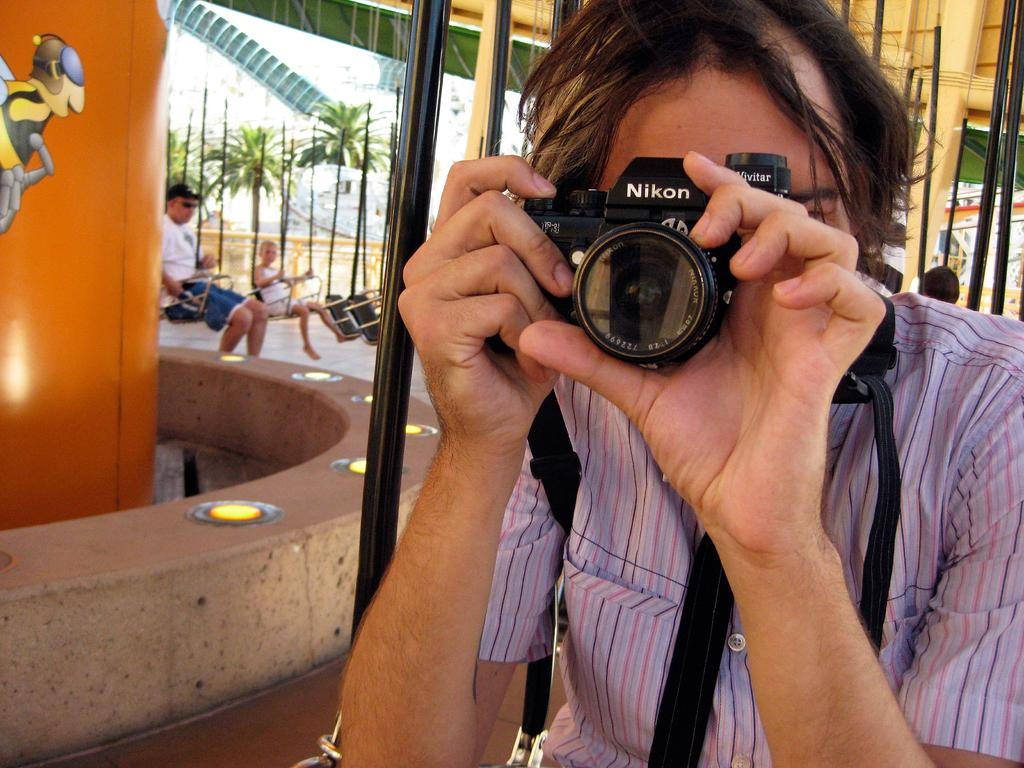What is the person in the image holding? The person in the image is holding a camera. What structures can be seen in the image? Poles are visible in the image. What type of vegetation is present in the image? There are trees in the image. How many people are in the image? There are people in the image. What color is the eye of the person in the image? There is no visible eye in the image, as the person is holding a camera and their face is not shown. 